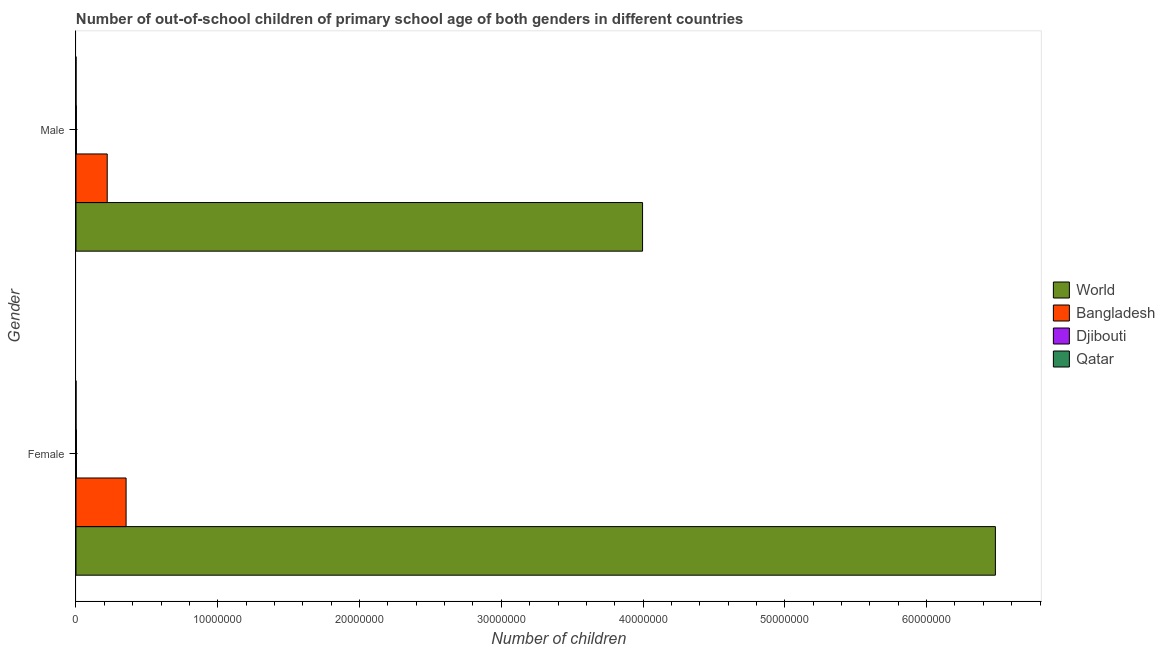Are the number of bars per tick equal to the number of legend labels?
Your answer should be very brief. Yes. How many bars are there on the 1st tick from the bottom?
Your response must be concise. 4. What is the number of male out-of-school students in Bangladesh?
Give a very brief answer. 2.20e+06. Across all countries, what is the maximum number of female out-of-school students?
Provide a short and direct response. 6.49e+07. Across all countries, what is the minimum number of female out-of-school students?
Ensure brevity in your answer.  2149. In which country was the number of female out-of-school students maximum?
Offer a very short reply. World. In which country was the number of female out-of-school students minimum?
Offer a terse response. Qatar. What is the total number of male out-of-school students in the graph?
Your answer should be very brief. 4.22e+07. What is the difference between the number of female out-of-school students in World and that in Qatar?
Provide a short and direct response. 6.49e+07. What is the difference between the number of female out-of-school students in Qatar and the number of male out-of-school students in World?
Provide a short and direct response. -4.00e+07. What is the average number of male out-of-school students per country?
Provide a succinct answer. 1.05e+07. What is the difference between the number of female out-of-school students and number of male out-of-school students in Bangladesh?
Ensure brevity in your answer.  1.33e+06. What is the ratio of the number of female out-of-school students in World to that in Bangladesh?
Your answer should be compact. 18.35. Is the number of female out-of-school students in Djibouti less than that in World?
Your answer should be compact. Yes. How many bars are there?
Provide a short and direct response. 8. Are all the bars in the graph horizontal?
Your answer should be very brief. Yes. How many countries are there in the graph?
Your answer should be compact. 4. Does the graph contain grids?
Offer a very short reply. No. How many legend labels are there?
Ensure brevity in your answer.  4. What is the title of the graph?
Ensure brevity in your answer.  Number of out-of-school children of primary school age of both genders in different countries. Does "Lithuania" appear as one of the legend labels in the graph?
Your answer should be compact. No. What is the label or title of the X-axis?
Offer a terse response. Number of children. What is the label or title of the Y-axis?
Your response must be concise. Gender. What is the Number of children in World in Female?
Offer a terse response. 6.49e+07. What is the Number of children of Bangladesh in Female?
Offer a very short reply. 3.53e+06. What is the Number of children in Djibouti in Female?
Provide a short and direct response. 3.08e+04. What is the Number of children in Qatar in Female?
Your answer should be very brief. 2149. What is the Number of children of World in Male?
Your response must be concise. 4.00e+07. What is the Number of children of Bangladesh in Male?
Keep it short and to the point. 2.20e+06. What is the Number of children of Djibouti in Male?
Provide a succinct answer. 2.77e+04. What is the Number of children of Qatar in Male?
Make the answer very short. 2249. Across all Gender, what is the maximum Number of children in World?
Provide a succinct answer. 6.49e+07. Across all Gender, what is the maximum Number of children of Bangladesh?
Ensure brevity in your answer.  3.53e+06. Across all Gender, what is the maximum Number of children in Djibouti?
Offer a very short reply. 3.08e+04. Across all Gender, what is the maximum Number of children in Qatar?
Give a very brief answer. 2249. Across all Gender, what is the minimum Number of children in World?
Ensure brevity in your answer.  4.00e+07. Across all Gender, what is the minimum Number of children of Bangladesh?
Make the answer very short. 2.20e+06. Across all Gender, what is the minimum Number of children of Djibouti?
Give a very brief answer. 2.77e+04. Across all Gender, what is the minimum Number of children of Qatar?
Give a very brief answer. 2149. What is the total Number of children in World in the graph?
Keep it short and to the point. 1.05e+08. What is the total Number of children of Bangladesh in the graph?
Provide a short and direct response. 5.74e+06. What is the total Number of children in Djibouti in the graph?
Offer a very short reply. 5.85e+04. What is the total Number of children of Qatar in the graph?
Your answer should be very brief. 4398. What is the difference between the Number of children in World in Female and that in Male?
Provide a succinct answer. 2.49e+07. What is the difference between the Number of children of Bangladesh in Female and that in Male?
Your answer should be very brief. 1.33e+06. What is the difference between the Number of children of Djibouti in Female and that in Male?
Offer a terse response. 3057. What is the difference between the Number of children in Qatar in Female and that in Male?
Offer a very short reply. -100. What is the difference between the Number of children in World in Female and the Number of children in Bangladesh in Male?
Offer a terse response. 6.27e+07. What is the difference between the Number of children of World in Female and the Number of children of Djibouti in Male?
Provide a succinct answer. 6.48e+07. What is the difference between the Number of children in World in Female and the Number of children in Qatar in Male?
Your answer should be compact. 6.49e+07. What is the difference between the Number of children in Bangladesh in Female and the Number of children in Djibouti in Male?
Provide a short and direct response. 3.51e+06. What is the difference between the Number of children in Bangladesh in Female and the Number of children in Qatar in Male?
Make the answer very short. 3.53e+06. What is the difference between the Number of children of Djibouti in Female and the Number of children of Qatar in Male?
Your answer should be very brief. 2.86e+04. What is the average Number of children in World per Gender?
Provide a short and direct response. 5.24e+07. What is the average Number of children in Bangladesh per Gender?
Your answer should be compact. 2.87e+06. What is the average Number of children in Djibouti per Gender?
Provide a short and direct response. 2.93e+04. What is the average Number of children of Qatar per Gender?
Offer a very short reply. 2199. What is the difference between the Number of children of World and Number of children of Bangladesh in Female?
Your answer should be very brief. 6.13e+07. What is the difference between the Number of children of World and Number of children of Djibouti in Female?
Ensure brevity in your answer.  6.48e+07. What is the difference between the Number of children in World and Number of children in Qatar in Female?
Offer a terse response. 6.49e+07. What is the difference between the Number of children of Bangladesh and Number of children of Djibouti in Female?
Provide a succinct answer. 3.50e+06. What is the difference between the Number of children of Bangladesh and Number of children of Qatar in Female?
Your answer should be very brief. 3.53e+06. What is the difference between the Number of children of Djibouti and Number of children of Qatar in Female?
Your answer should be very brief. 2.86e+04. What is the difference between the Number of children in World and Number of children in Bangladesh in Male?
Ensure brevity in your answer.  3.78e+07. What is the difference between the Number of children in World and Number of children in Djibouti in Male?
Provide a short and direct response. 3.99e+07. What is the difference between the Number of children in World and Number of children in Qatar in Male?
Offer a terse response. 4.00e+07. What is the difference between the Number of children of Bangladesh and Number of children of Djibouti in Male?
Give a very brief answer. 2.17e+06. What is the difference between the Number of children of Bangladesh and Number of children of Qatar in Male?
Your response must be concise. 2.20e+06. What is the difference between the Number of children of Djibouti and Number of children of Qatar in Male?
Make the answer very short. 2.55e+04. What is the ratio of the Number of children of World in Female to that in Male?
Your answer should be compact. 1.62. What is the ratio of the Number of children of Bangladesh in Female to that in Male?
Provide a short and direct response. 1.6. What is the ratio of the Number of children in Djibouti in Female to that in Male?
Offer a very short reply. 1.11. What is the ratio of the Number of children of Qatar in Female to that in Male?
Keep it short and to the point. 0.96. What is the difference between the highest and the second highest Number of children in World?
Offer a very short reply. 2.49e+07. What is the difference between the highest and the second highest Number of children of Bangladesh?
Offer a terse response. 1.33e+06. What is the difference between the highest and the second highest Number of children in Djibouti?
Your answer should be compact. 3057. What is the difference between the highest and the lowest Number of children of World?
Ensure brevity in your answer.  2.49e+07. What is the difference between the highest and the lowest Number of children of Bangladesh?
Your response must be concise. 1.33e+06. What is the difference between the highest and the lowest Number of children of Djibouti?
Provide a short and direct response. 3057. What is the difference between the highest and the lowest Number of children of Qatar?
Offer a very short reply. 100. 